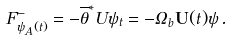Convert formula to latex. <formula><loc_0><loc_0><loc_500><loc_500>F ^ { - } _ { \psi _ { A } ( t ) } = - \overline { \theta } ^ { * } U \psi _ { t } = - \Omega _ { b } \mathbf U ( t ) \psi \, .</formula> 